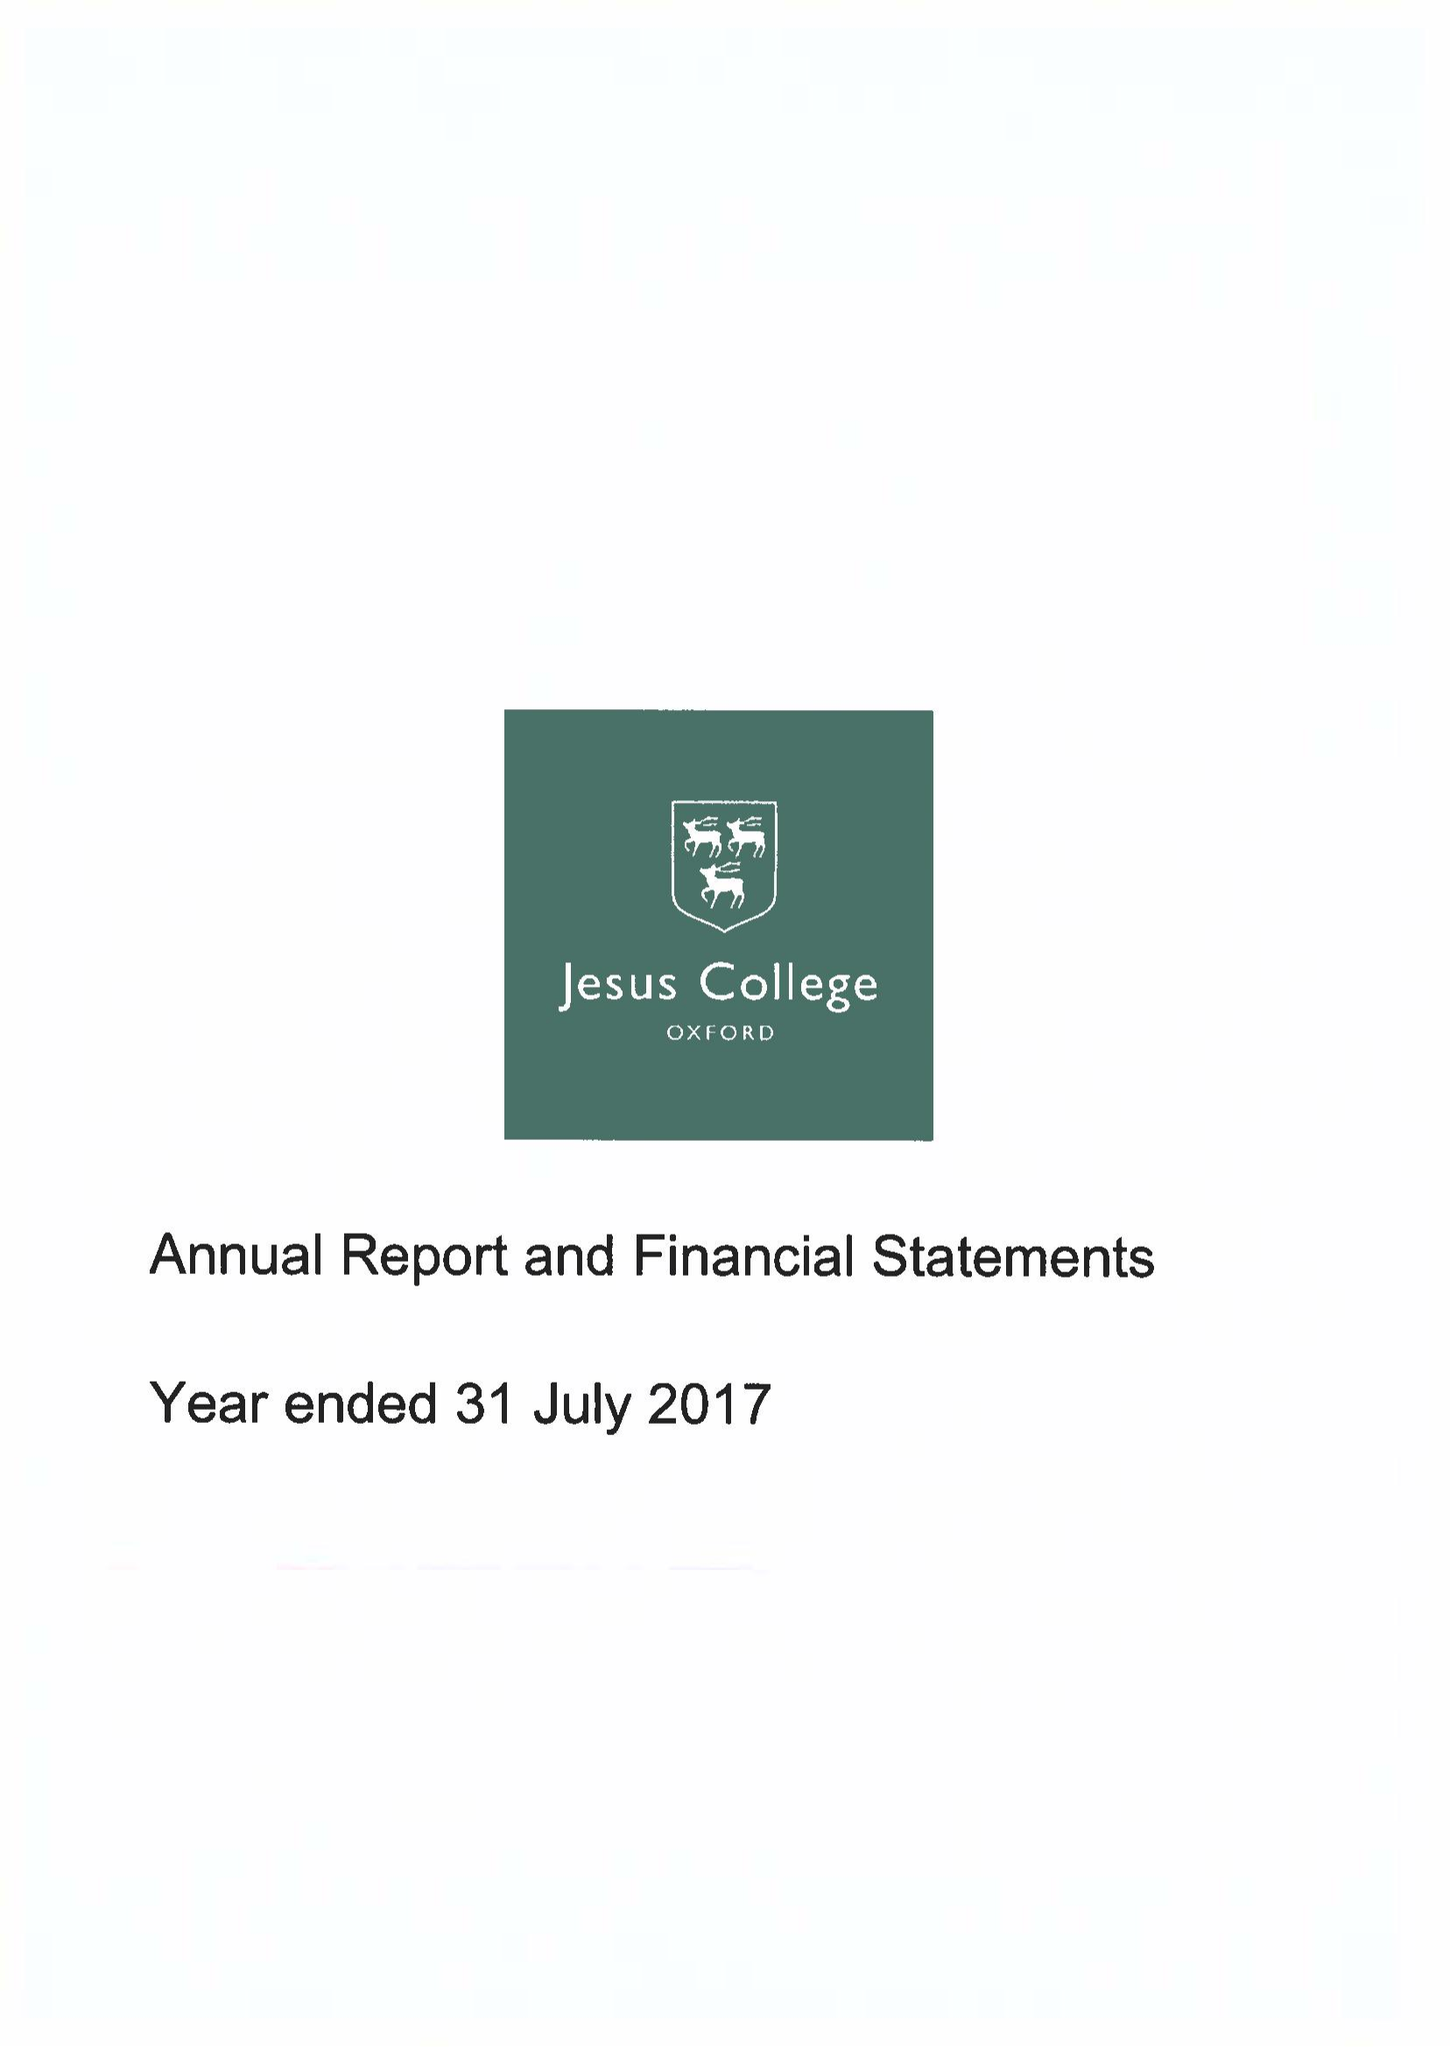What is the value for the address__postcode?
Answer the question using a single word or phrase. OX1 3DW 